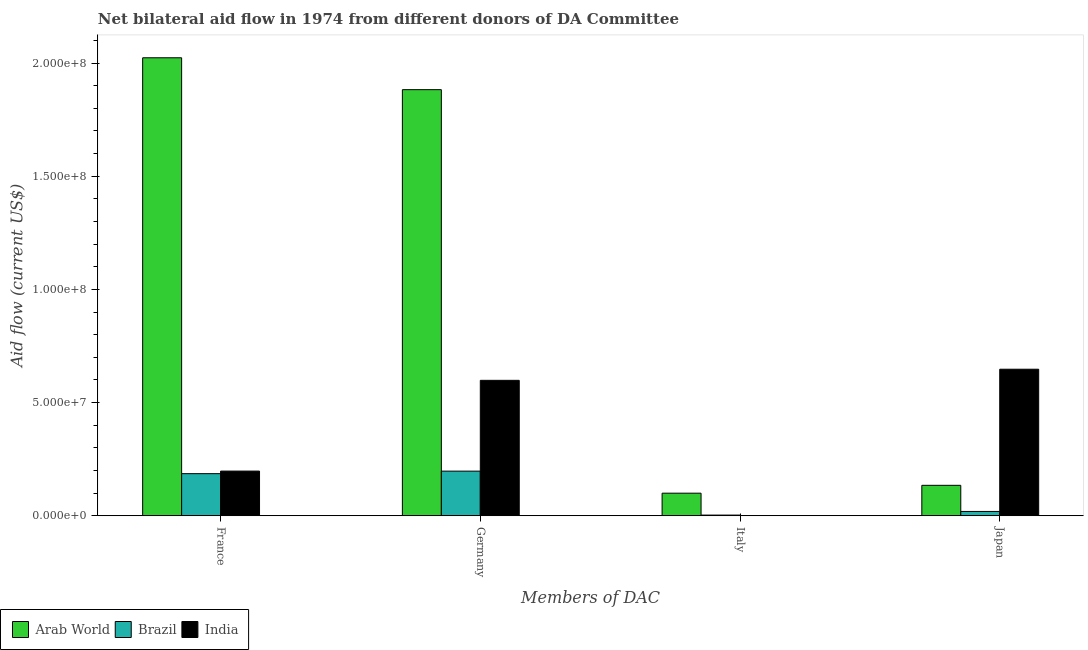Are the number of bars per tick equal to the number of legend labels?
Ensure brevity in your answer.  No. How many bars are there on the 3rd tick from the right?
Keep it short and to the point. 3. What is the label of the 3rd group of bars from the left?
Give a very brief answer. Italy. What is the amount of aid given by france in Arab World?
Your response must be concise. 2.02e+08. Across all countries, what is the maximum amount of aid given by italy?
Your answer should be compact. 9.99e+06. In which country was the amount of aid given by italy maximum?
Make the answer very short. Arab World. What is the total amount of aid given by france in the graph?
Keep it short and to the point. 2.41e+08. What is the difference between the amount of aid given by japan in India and that in Brazil?
Ensure brevity in your answer.  6.28e+07. What is the difference between the amount of aid given by japan in Brazil and the amount of aid given by germany in India?
Give a very brief answer. -5.79e+07. What is the average amount of aid given by france per country?
Ensure brevity in your answer.  8.02e+07. What is the difference between the amount of aid given by japan and amount of aid given by france in Brazil?
Provide a short and direct response. -1.67e+07. In how many countries, is the amount of aid given by italy greater than 90000000 US$?
Provide a short and direct response. 0. What is the ratio of the amount of aid given by france in India to that in Arab World?
Your answer should be compact. 0.1. What is the difference between the highest and the second highest amount of aid given by germany?
Offer a terse response. 1.28e+08. What is the difference between the highest and the lowest amount of aid given by france?
Give a very brief answer. 1.84e+08. Is the sum of the amount of aid given by france in India and Brazil greater than the maximum amount of aid given by japan across all countries?
Your answer should be very brief. No. Is it the case that in every country, the sum of the amount of aid given by italy and amount of aid given by germany is greater than the sum of amount of aid given by japan and amount of aid given by france?
Your answer should be compact. No. Is it the case that in every country, the sum of the amount of aid given by france and amount of aid given by germany is greater than the amount of aid given by italy?
Provide a succinct answer. Yes. How many bars are there?
Ensure brevity in your answer.  11. Are all the bars in the graph horizontal?
Keep it short and to the point. No. How many countries are there in the graph?
Your answer should be very brief. 3. Are the values on the major ticks of Y-axis written in scientific E-notation?
Ensure brevity in your answer.  Yes. Does the graph contain grids?
Your answer should be very brief. No. How are the legend labels stacked?
Provide a short and direct response. Horizontal. What is the title of the graph?
Provide a short and direct response. Net bilateral aid flow in 1974 from different donors of DA Committee. Does "Small states" appear as one of the legend labels in the graph?
Keep it short and to the point. No. What is the label or title of the X-axis?
Make the answer very short. Members of DAC. What is the label or title of the Y-axis?
Provide a succinct answer. Aid flow (current US$). What is the Aid flow (current US$) in Arab World in France?
Your answer should be very brief. 2.02e+08. What is the Aid flow (current US$) of Brazil in France?
Offer a terse response. 1.86e+07. What is the Aid flow (current US$) of India in France?
Make the answer very short. 1.98e+07. What is the Aid flow (current US$) in Arab World in Germany?
Your answer should be compact. 1.88e+08. What is the Aid flow (current US$) in Brazil in Germany?
Ensure brevity in your answer.  1.97e+07. What is the Aid flow (current US$) of India in Germany?
Your answer should be very brief. 5.98e+07. What is the Aid flow (current US$) in Arab World in Italy?
Your answer should be very brief. 9.99e+06. What is the Aid flow (current US$) of India in Italy?
Give a very brief answer. 0. What is the Aid flow (current US$) of Arab World in Japan?
Your answer should be very brief. 1.35e+07. What is the Aid flow (current US$) in Brazil in Japan?
Give a very brief answer. 1.92e+06. What is the Aid flow (current US$) in India in Japan?
Give a very brief answer. 6.48e+07. Across all Members of DAC, what is the maximum Aid flow (current US$) in Arab World?
Provide a succinct answer. 2.02e+08. Across all Members of DAC, what is the maximum Aid flow (current US$) in Brazil?
Offer a terse response. 1.97e+07. Across all Members of DAC, what is the maximum Aid flow (current US$) of India?
Your answer should be very brief. 6.48e+07. Across all Members of DAC, what is the minimum Aid flow (current US$) of Arab World?
Provide a succinct answer. 9.99e+06. Across all Members of DAC, what is the minimum Aid flow (current US$) of Brazil?
Provide a succinct answer. 3.10e+05. Across all Members of DAC, what is the minimum Aid flow (current US$) in India?
Make the answer very short. 0. What is the total Aid flow (current US$) in Arab World in the graph?
Give a very brief answer. 4.14e+08. What is the total Aid flow (current US$) in Brazil in the graph?
Give a very brief answer. 4.06e+07. What is the total Aid flow (current US$) of India in the graph?
Ensure brevity in your answer.  1.44e+08. What is the difference between the Aid flow (current US$) of Arab World in France and that in Germany?
Offer a very short reply. 1.41e+07. What is the difference between the Aid flow (current US$) of Brazil in France and that in Germany?
Provide a short and direct response. -1.12e+06. What is the difference between the Aid flow (current US$) in India in France and that in Germany?
Provide a short and direct response. -4.01e+07. What is the difference between the Aid flow (current US$) of Arab World in France and that in Italy?
Make the answer very short. 1.92e+08. What is the difference between the Aid flow (current US$) of Brazil in France and that in Italy?
Provide a short and direct response. 1.83e+07. What is the difference between the Aid flow (current US$) of Arab World in France and that in Japan?
Provide a short and direct response. 1.89e+08. What is the difference between the Aid flow (current US$) of Brazil in France and that in Japan?
Provide a short and direct response. 1.67e+07. What is the difference between the Aid flow (current US$) in India in France and that in Japan?
Keep it short and to the point. -4.50e+07. What is the difference between the Aid flow (current US$) of Arab World in Germany and that in Italy?
Offer a very short reply. 1.78e+08. What is the difference between the Aid flow (current US$) in Brazil in Germany and that in Italy?
Your response must be concise. 1.94e+07. What is the difference between the Aid flow (current US$) of Arab World in Germany and that in Japan?
Offer a terse response. 1.75e+08. What is the difference between the Aid flow (current US$) of Brazil in Germany and that in Japan?
Offer a terse response. 1.78e+07. What is the difference between the Aid flow (current US$) of India in Germany and that in Japan?
Provide a short and direct response. -4.91e+06. What is the difference between the Aid flow (current US$) of Arab World in Italy and that in Japan?
Give a very brief answer. -3.47e+06. What is the difference between the Aid flow (current US$) of Brazil in Italy and that in Japan?
Make the answer very short. -1.61e+06. What is the difference between the Aid flow (current US$) in Arab World in France and the Aid flow (current US$) in Brazil in Germany?
Offer a very short reply. 1.83e+08. What is the difference between the Aid flow (current US$) in Arab World in France and the Aid flow (current US$) in India in Germany?
Keep it short and to the point. 1.42e+08. What is the difference between the Aid flow (current US$) of Brazil in France and the Aid flow (current US$) of India in Germany?
Provide a short and direct response. -4.12e+07. What is the difference between the Aid flow (current US$) of Arab World in France and the Aid flow (current US$) of Brazil in Italy?
Provide a short and direct response. 2.02e+08. What is the difference between the Aid flow (current US$) of Arab World in France and the Aid flow (current US$) of Brazil in Japan?
Keep it short and to the point. 2.00e+08. What is the difference between the Aid flow (current US$) in Arab World in France and the Aid flow (current US$) in India in Japan?
Your response must be concise. 1.38e+08. What is the difference between the Aid flow (current US$) in Brazil in France and the Aid flow (current US$) in India in Japan?
Provide a succinct answer. -4.61e+07. What is the difference between the Aid flow (current US$) in Arab World in Germany and the Aid flow (current US$) in Brazil in Italy?
Provide a short and direct response. 1.88e+08. What is the difference between the Aid flow (current US$) of Arab World in Germany and the Aid flow (current US$) of Brazil in Japan?
Offer a terse response. 1.86e+08. What is the difference between the Aid flow (current US$) of Arab World in Germany and the Aid flow (current US$) of India in Japan?
Offer a terse response. 1.24e+08. What is the difference between the Aid flow (current US$) in Brazil in Germany and the Aid flow (current US$) in India in Japan?
Ensure brevity in your answer.  -4.50e+07. What is the difference between the Aid flow (current US$) in Arab World in Italy and the Aid flow (current US$) in Brazil in Japan?
Offer a very short reply. 8.07e+06. What is the difference between the Aid flow (current US$) of Arab World in Italy and the Aid flow (current US$) of India in Japan?
Give a very brief answer. -5.48e+07. What is the difference between the Aid flow (current US$) of Brazil in Italy and the Aid flow (current US$) of India in Japan?
Make the answer very short. -6.44e+07. What is the average Aid flow (current US$) in Arab World per Members of DAC?
Your response must be concise. 1.04e+08. What is the average Aid flow (current US$) of Brazil per Members of DAC?
Ensure brevity in your answer.  1.01e+07. What is the average Aid flow (current US$) of India per Members of DAC?
Provide a short and direct response. 3.61e+07. What is the difference between the Aid flow (current US$) of Arab World and Aid flow (current US$) of Brazil in France?
Your response must be concise. 1.84e+08. What is the difference between the Aid flow (current US$) of Arab World and Aid flow (current US$) of India in France?
Offer a terse response. 1.83e+08. What is the difference between the Aid flow (current US$) of Brazil and Aid flow (current US$) of India in France?
Your response must be concise. -1.14e+06. What is the difference between the Aid flow (current US$) of Arab World and Aid flow (current US$) of Brazil in Germany?
Offer a terse response. 1.69e+08. What is the difference between the Aid flow (current US$) of Arab World and Aid flow (current US$) of India in Germany?
Offer a terse response. 1.28e+08. What is the difference between the Aid flow (current US$) of Brazil and Aid flow (current US$) of India in Germany?
Keep it short and to the point. -4.01e+07. What is the difference between the Aid flow (current US$) in Arab World and Aid flow (current US$) in Brazil in Italy?
Provide a succinct answer. 9.68e+06. What is the difference between the Aid flow (current US$) in Arab World and Aid flow (current US$) in Brazil in Japan?
Your answer should be very brief. 1.15e+07. What is the difference between the Aid flow (current US$) in Arab World and Aid flow (current US$) in India in Japan?
Offer a terse response. -5.13e+07. What is the difference between the Aid flow (current US$) of Brazil and Aid flow (current US$) of India in Japan?
Your answer should be compact. -6.28e+07. What is the ratio of the Aid flow (current US$) in Arab World in France to that in Germany?
Offer a very short reply. 1.07. What is the ratio of the Aid flow (current US$) of Brazil in France to that in Germany?
Offer a very short reply. 0.94. What is the ratio of the Aid flow (current US$) in India in France to that in Germany?
Keep it short and to the point. 0.33. What is the ratio of the Aid flow (current US$) of Arab World in France to that in Italy?
Your answer should be very brief. 20.25. What is the ratio of the Aid flow (current US$) in Brazil in France to that in Italy?
Keep it short and to the point. 60.03. What is the ratio of the Aid flow (current US$) in Arab World in France to that in Japan?
Your answer should be compact. 15.03. What is the ratio of the Aid flow (current US$) in Brazil in France to that in Japan?
Make the answer very short. 9.69. What is the ratio of the Aid flow (current US$) of India in France to that in Japan?
Offer a terse response. 0.3. What is the ratio of the Aid flow (current US$) of Arab World in Germany to that in Italy?
Your response must be concise. 18.84. What is the ratio of the Aid flow (current US$) in Brazil in Germany to that in Italy?
Offer a terse response. 63.65. What is the ratio of the Aid flow (current US$) in Arab World in Germany to that in Japan?
Offer a terse response. 13.99. What is the ratio of the Aid flow (current US$) of Brazil in Germany to that in Japan?
Keep it short and to the point. 10.28. What is the ratio of the Aid flow (current US$) in India in Germany to that in Japan?
Make the answer very short. 0.92. What is the ratio of the Aid flow (current US$) of Arab World in Italy to that in Japan?
Make the answer very short. 0.74. What is the ratio of the Aid flow (current US$) in Brazil in Italy to that in Japan?
Your answer should be very brief. 0.16. What is the difference between the highest and the second highest Aid flow (current US$) of Arab World?
Your answer should be very brief. 1.41e+07. What is the difference between the highest and the second highest Aid flow (current US$) of Brazil?
Keep it short and to the point. 1.12e+06. What is the difference between the highest and the second highest Aid flow (current US$) in India?
Offer a terse response. 4.91e+06. What is the difference between the highest and the lowest Aid flow (current US$) in Arab World?
Give a very brief answer. 1.92e+08. What is the difference between the highest and the lowest Aid flow (current US$) in Brazil?
Make the answer very short. 1.94e+07. What is the difference between the highest and the lowest Aid flow (current US$) in India?
Offer a very short reply. 6.48e+07. 